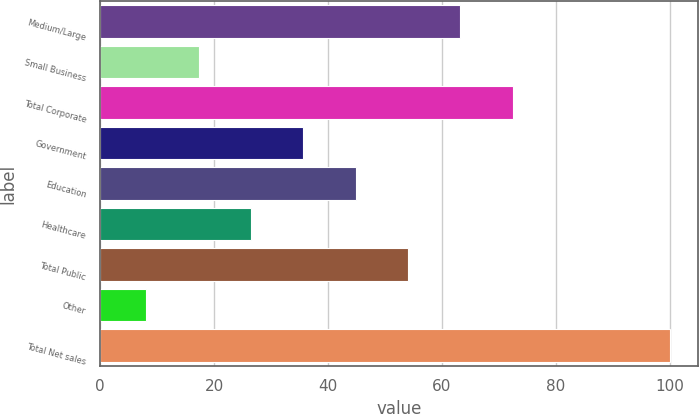Convert chart to OTSL. <chart><loc_0><loc_0><loc_500><loc_500><bar_chart><fcel>Medium/Large<fcel>Small Business<fcel>Total Corporate<fcel>Government<fcel>Education<fcel>Healthcare<fcel>Total Public<fcel>Other<fcel>Total Net sales<nl><fcel>63.24<fcel>17.29<fcel>72.43<fcel>35.67<fcel>44.86<fcel>26.48<fcel>54.05<fcel>8.1<fcel>100<nl></chart> 